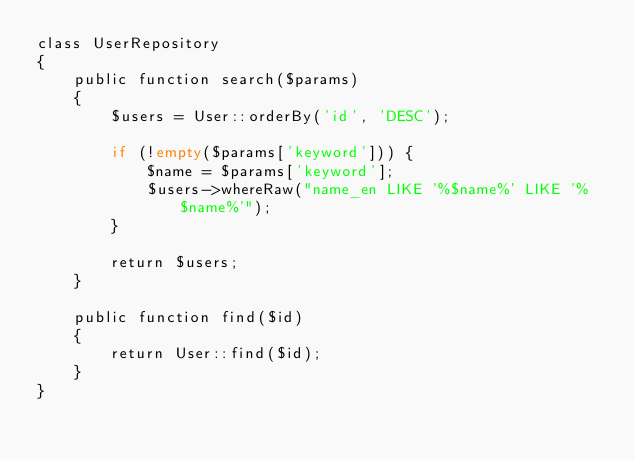<code> <loc_0><loc_0><loc_500><loc_500><_PHP_>class UserRepository
{
    public function search($params)
    {
        $users = User::orderBy('id', 'DESC');

        if (!empty($params['keyword'])) {
            $name = $params['keyword'];
            $users->whereRaw("name_en LIKE '%$name%' LIKE '%$name%'");
        }

        return $users;
    }

    public function find($id)
    {
        return User::find($id);
    }
}
</code> 